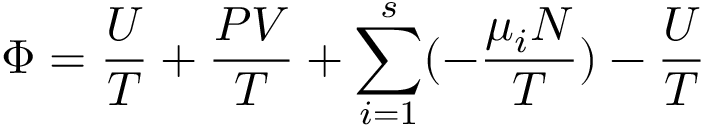Convert formula to latex. <formula><loc_0><loc_0><loc_500><loc_500>\Phi = { \frac { U } { T } } + { \frac { P V } { T } } + \sum _ { i = 1 } ^ { s } ( - { \frac { \mu _ { i } N } { T } } ) - { \frac { U } { T } }</formula> 